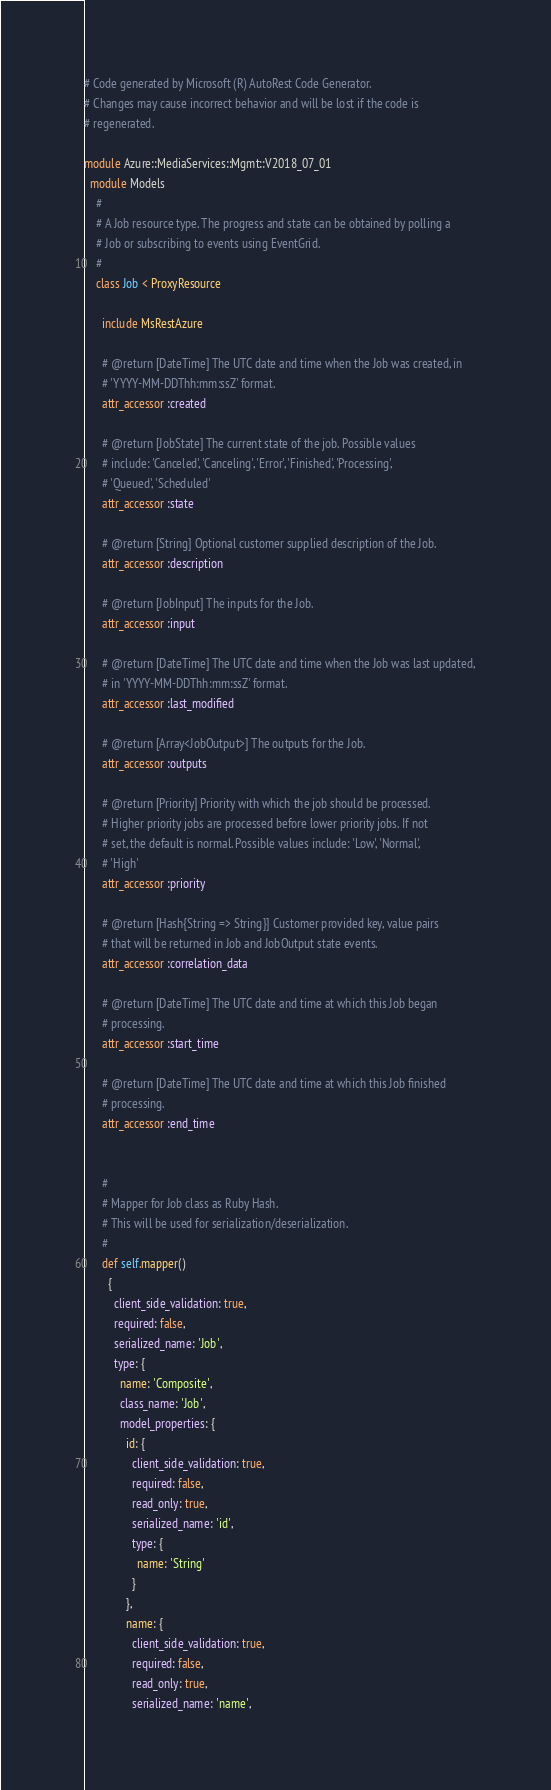<code> <loc_0><loc_0><loc_500><loc_500><_Ruby_># Code generated by Microsoft (R) AutoRest Code Generator.
# Changes may cause incorrect behavior and will be lost if the code is
# regenerated.

module Azure::MediaServices::Mgmt::V2018_07_01
  module Models
    #
    # A Job resource type. The progress and state can be obtained by polling a
    # Job or subscribing to events using EventGrid.
    #
    class Job < ProxyResource

      include MsRestAzure

      # @return [DateTime] The UTC date and time when the Job was created, in
      # 'YYYY-MM-DDThh:mm:ssZ' format.
      attr_accessor :created

      # @return [JobState] The current state of the job. Possible values
      # include: 'Canceled', 'Canceling', 'Error', 'Finished', 'Processing',
      # 'Queued', 'Scheduled'
      attr_accessor :state

      # @return [String] Optional customer supplied description of the Job.
      attr_accessor :description

      # @return [JobInput] The inputs for the Job.
      attr_accessor :input

      # @return [DateTime] The UTC date and time when the Job was last updated,
      # in 'YYYY-MM-DDThh:mm:ssZ' format.
      attr_accessor :last_modified

      # @return [Array<JobOutput>] The outputs for the Job.
      attr_accessor :outputs

      # @return [Priority] Priority with which the job should be processed.
      # Higher priority jobs are processed before lower priority jobs. If not
      # set, the default is normal. Possible values include: 'Low', 'Normal',
      # 'High'
      attr_accessor :priority

      # @return [Hash{String => String}] Customer provided key, value pairs
      # that will be returned in Job and JobOutput state events.
      attr_accessor :correlation_data

      # @return [DateTime] The UTC date and time at which this Job began
      # processing.
      attr_accessor :start_time

      # @return [DateTime] The UTC date and time at which this Job finished
      # processing.
      attr_accessor :end_time


      #
      # Mapper for Job class as Ruby Hash.
      # This will be used for serialization/deserialization.
      #
      def self.mapper()
        {
          client_side_validation: true,
          required: false,
          serialized_name: 'Job',
          type: {
            name: 'Composite',
            class_name: 'Job',
            model_properties: {
              id: {
                client_side_validation: true,
                required: false,
                read_only: true,
                serialized_name: 'id',
                type: {
                  name: 'String'
                }
              },
              name: {
                client_side_validation: true,
                required: false,
                read_only: true,
                serialized_name: 'name',</code> 